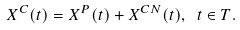<formula> <loc_0><loc_0><loc_500><loc_500>X ^ { C } ( t ) = X ^ { P } ( t ) + X ^ { C N } ( t ) , \ t \in T .</formula> 